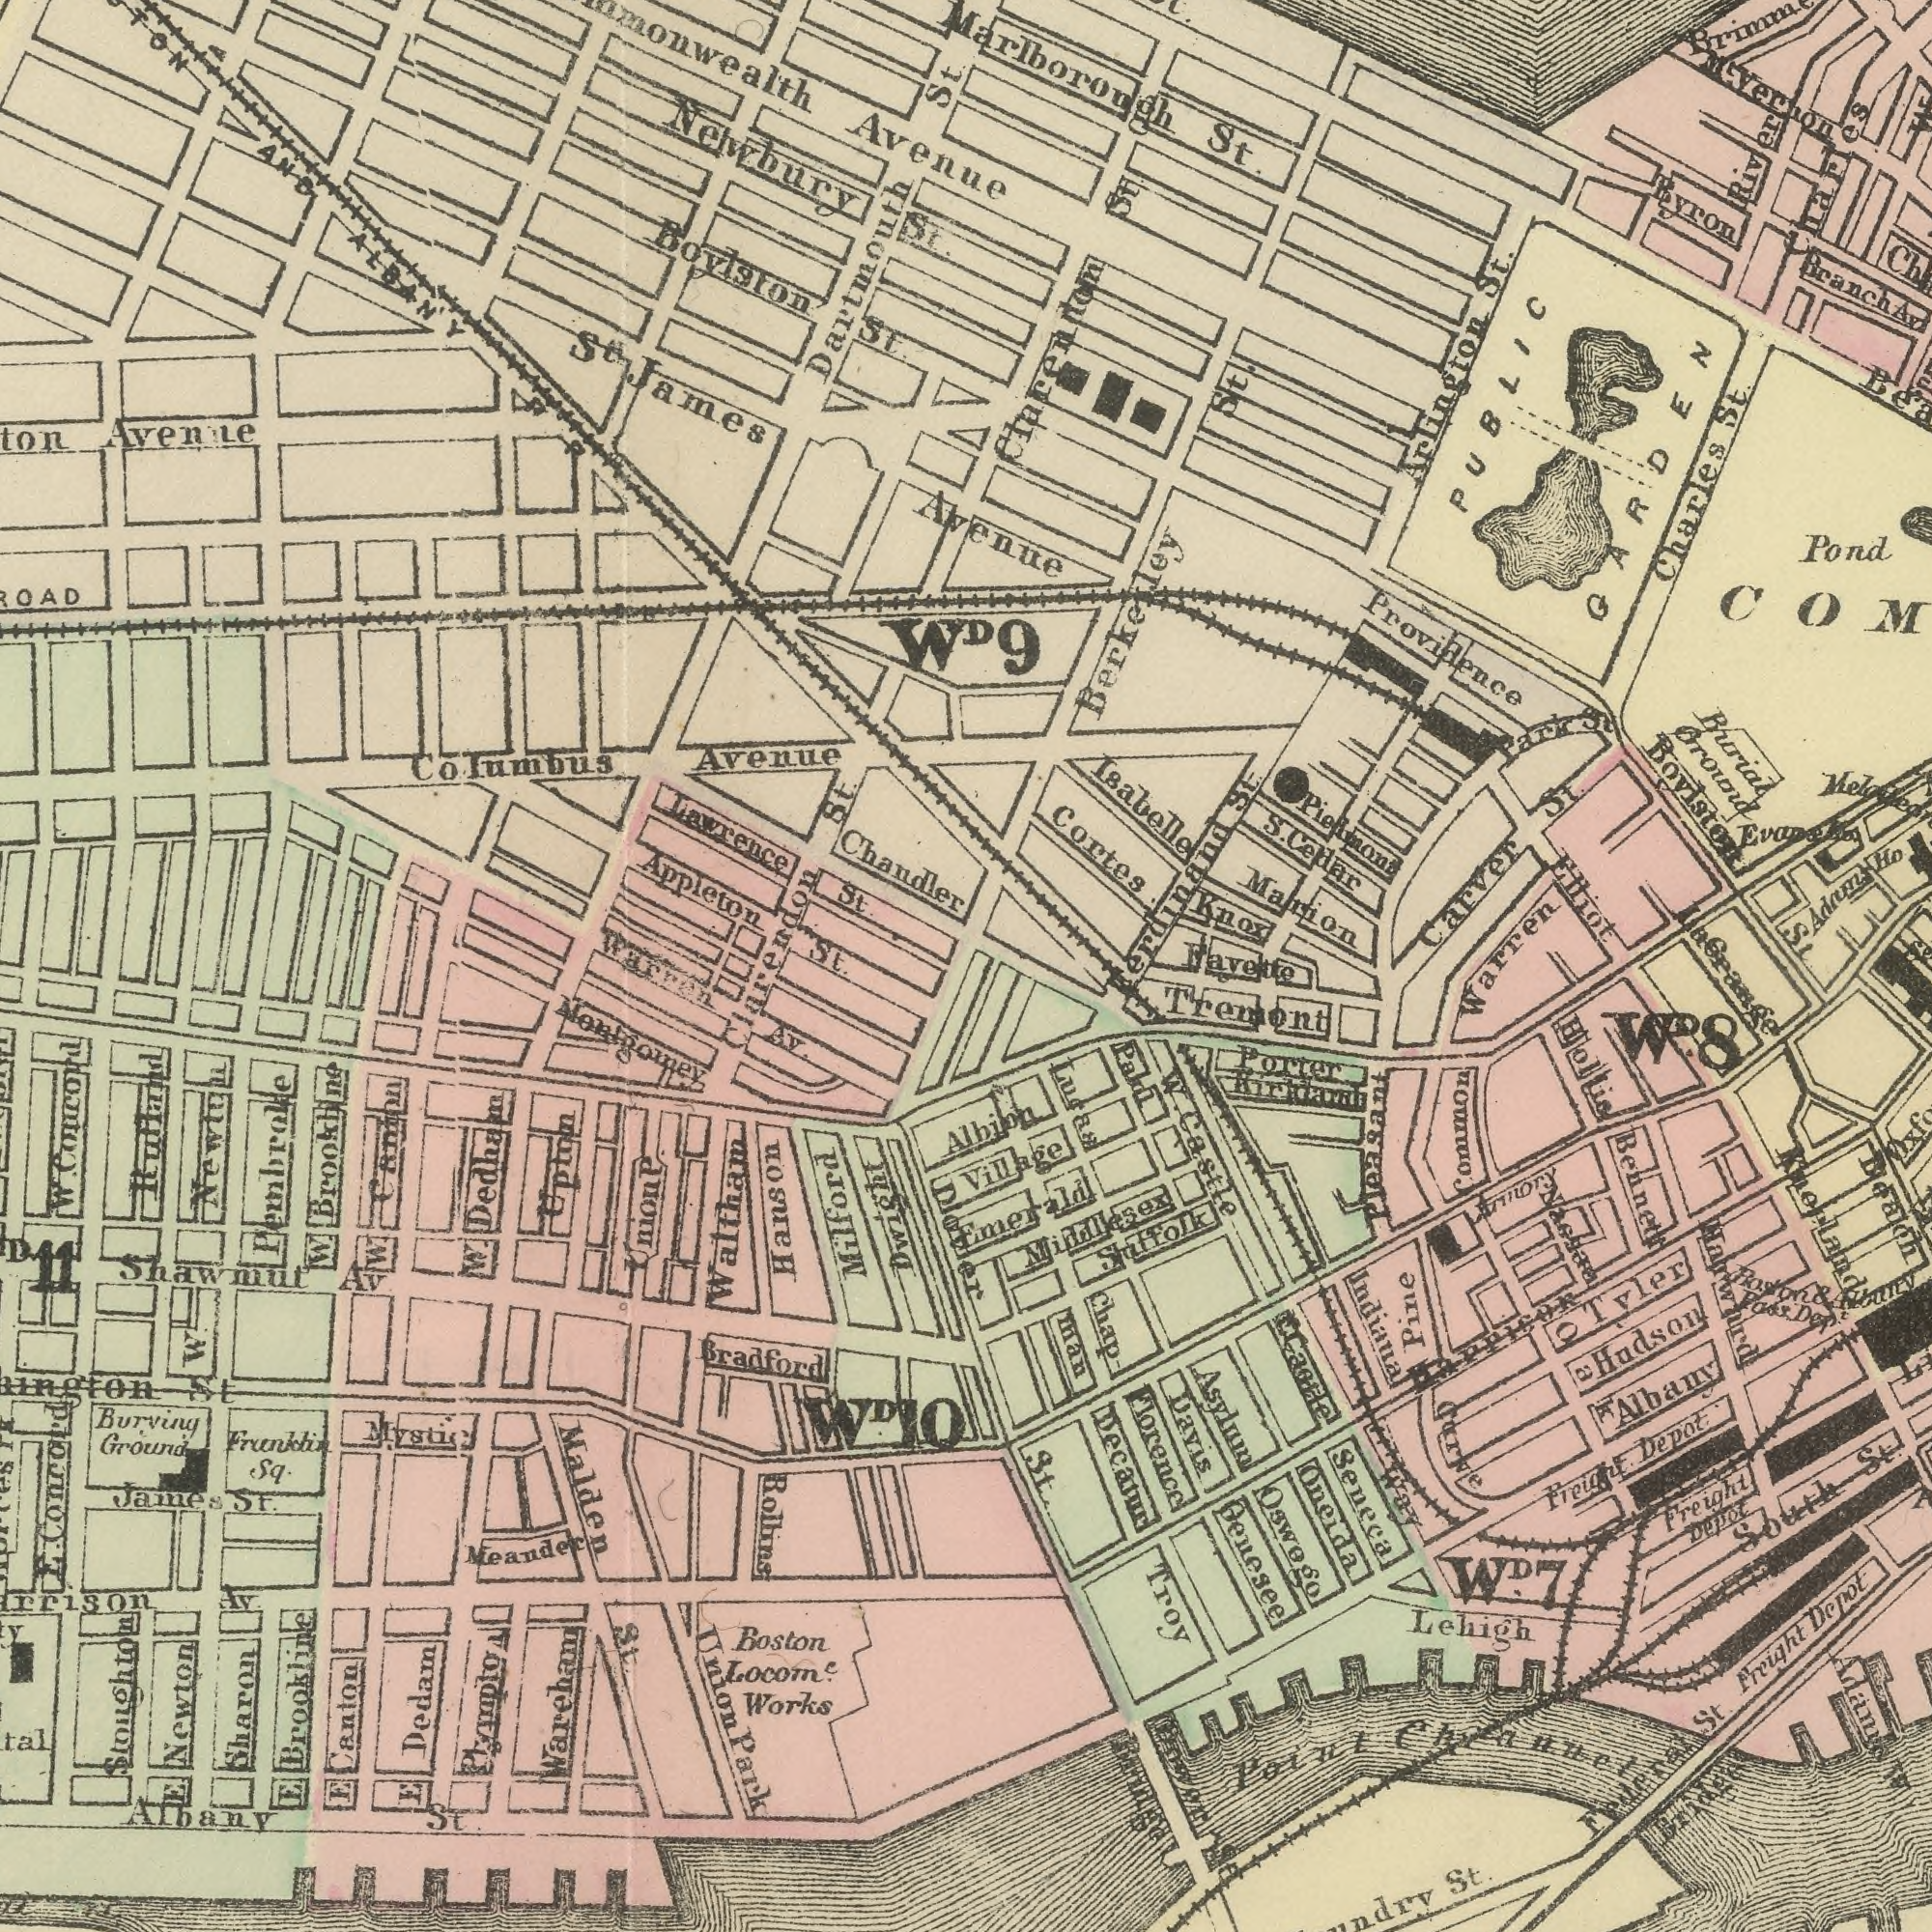What text appears in the top-right area of the image? Avenue 9 Marion Boylsten St. Isabelle Cortes Pond Providence Charles St. Marlborough St. Arlington St. Knox Pienmont Buriat Ground Carver St. Adam Ho River Berkerley St. Elliot Byron Ferdinand St. PUBLIC GARDEN Clarendon St. Myernon Park St Melateon S. Celdar Branch Av Charles What text can you see in the bottom-left section? St. Clarendon Warran AV. Pembroke Albany St. W. Concord E Brookline Sharon Waltham Malden St. Av. E Dedam Boston Locom.<sup>e</sup> Works W. Dedham Meander Burving Ground W. Brookline Warehanu W. Newton E Canton Union Park E Newton James St. Shawmut Av W. Franklin Sq. Bollins Conrard Mystic Hulland Diovier Nontgalney 11 St Union P. Bradford W.<sup>D</sup> 10 Upton Hanson Dwight Milford E. What text is shown in the bottom-right quadrant? Lacpange Common Warren St. Bennett Qeuesee Bealch Indiana Tremont St. Florence Decatur Lehigh Troy Freight Depot. Hollis Pine Hudson South St. Freight Depot Freight Depot Davis Porter W. Castle Than Carve Federal St. Chap Point Channel Seneca Village Middllsex Qneida Statfolk Way Paln Albion Tvler Lugaa Oswogo Emerald knorland Post Dep Asylum W Armory Bridge Happis Albany Oak Roston & Hbnny Pleasant W.<sup>D</sup> 8 Ravette W.<sup>D</sup> 7 Bridge Power St Naesar What text appears in the top-left area of the image? Boylston St. Lawrence St. Newbury St. Chandler Appleton S<sup>t</sup>. James Dartmouth St. Columbus Avenue Avenue Avenile St. AND ALBANY DR W<sup>D</sup>. 